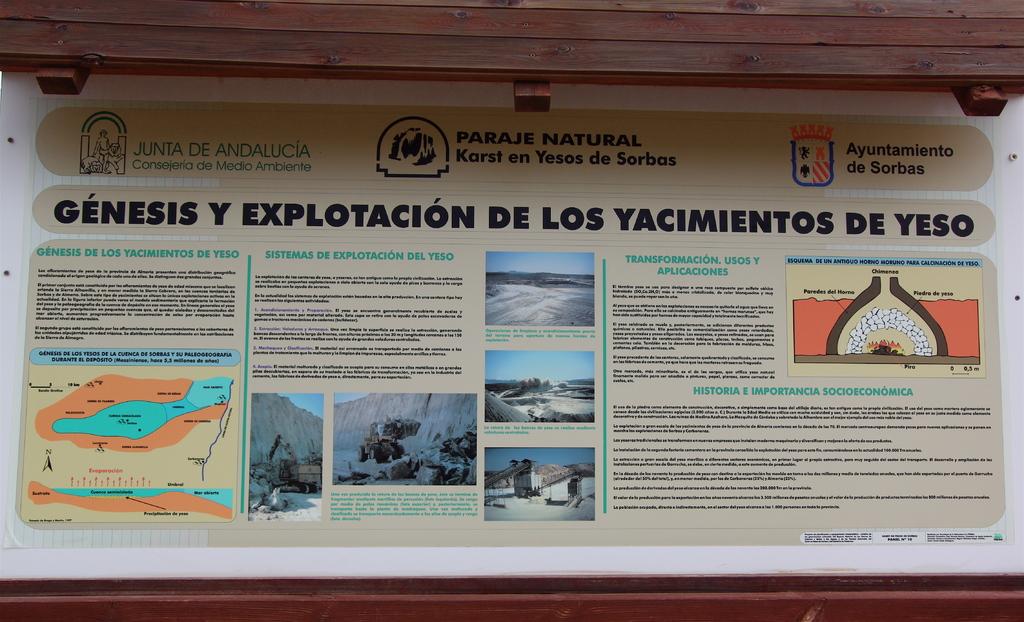What is the title of the article?
Ensure brevity in your answer.  Genesis y explotacion de los yacimientos de yeso. 